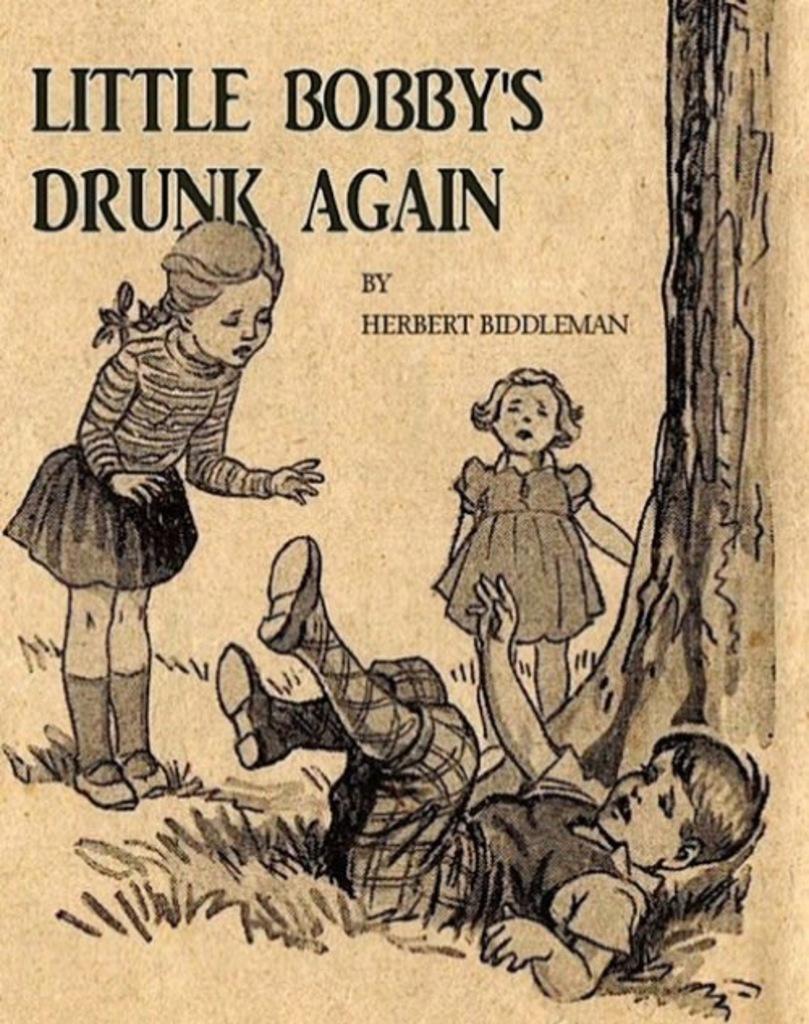Can you describe this image briefly? In this picture I can see the depiction of 3 children in front and I see the grass and a tree and I see something is written on top of this picture. 